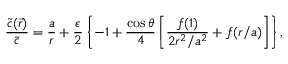<formula> <loc_0><loc_0><loc_500><loc_500>\frac { \tilde { c } ( \vec { r } ) } { \bar { c } } = \frac { a } { r } + \frac { \epsilon } { 2 } \left \{ - 1 + \frac { \cos \theta } { 4 } \left [ \frac { f ( 1 ) } { 2 r ^ { 2 } / a ^ { 2 } } + f ( r / a ) \right ] \right \} ,</formula> 